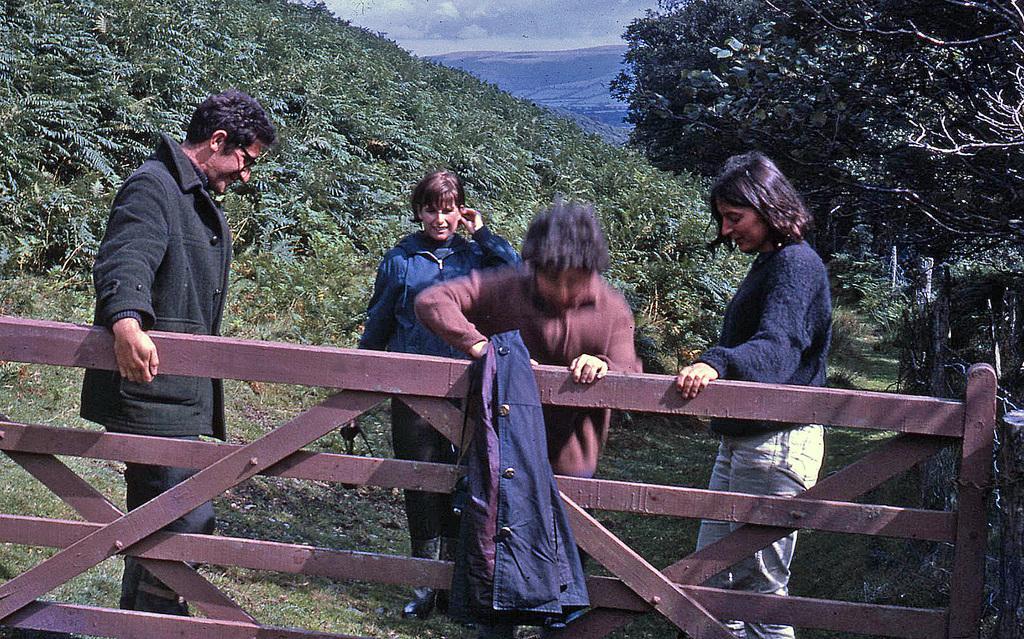Please provide a concise description of this image. At the bottom of the picture, we see grass and a brown color wooden railing. We see a blue jerkin is on the railing. Beside that, we see four people are standing. The man in black jacket who is wearing spectacles is smiling. On the right side, we see the trees. In the background, there are trees and hills. At the top of the picture, we see the sky. 